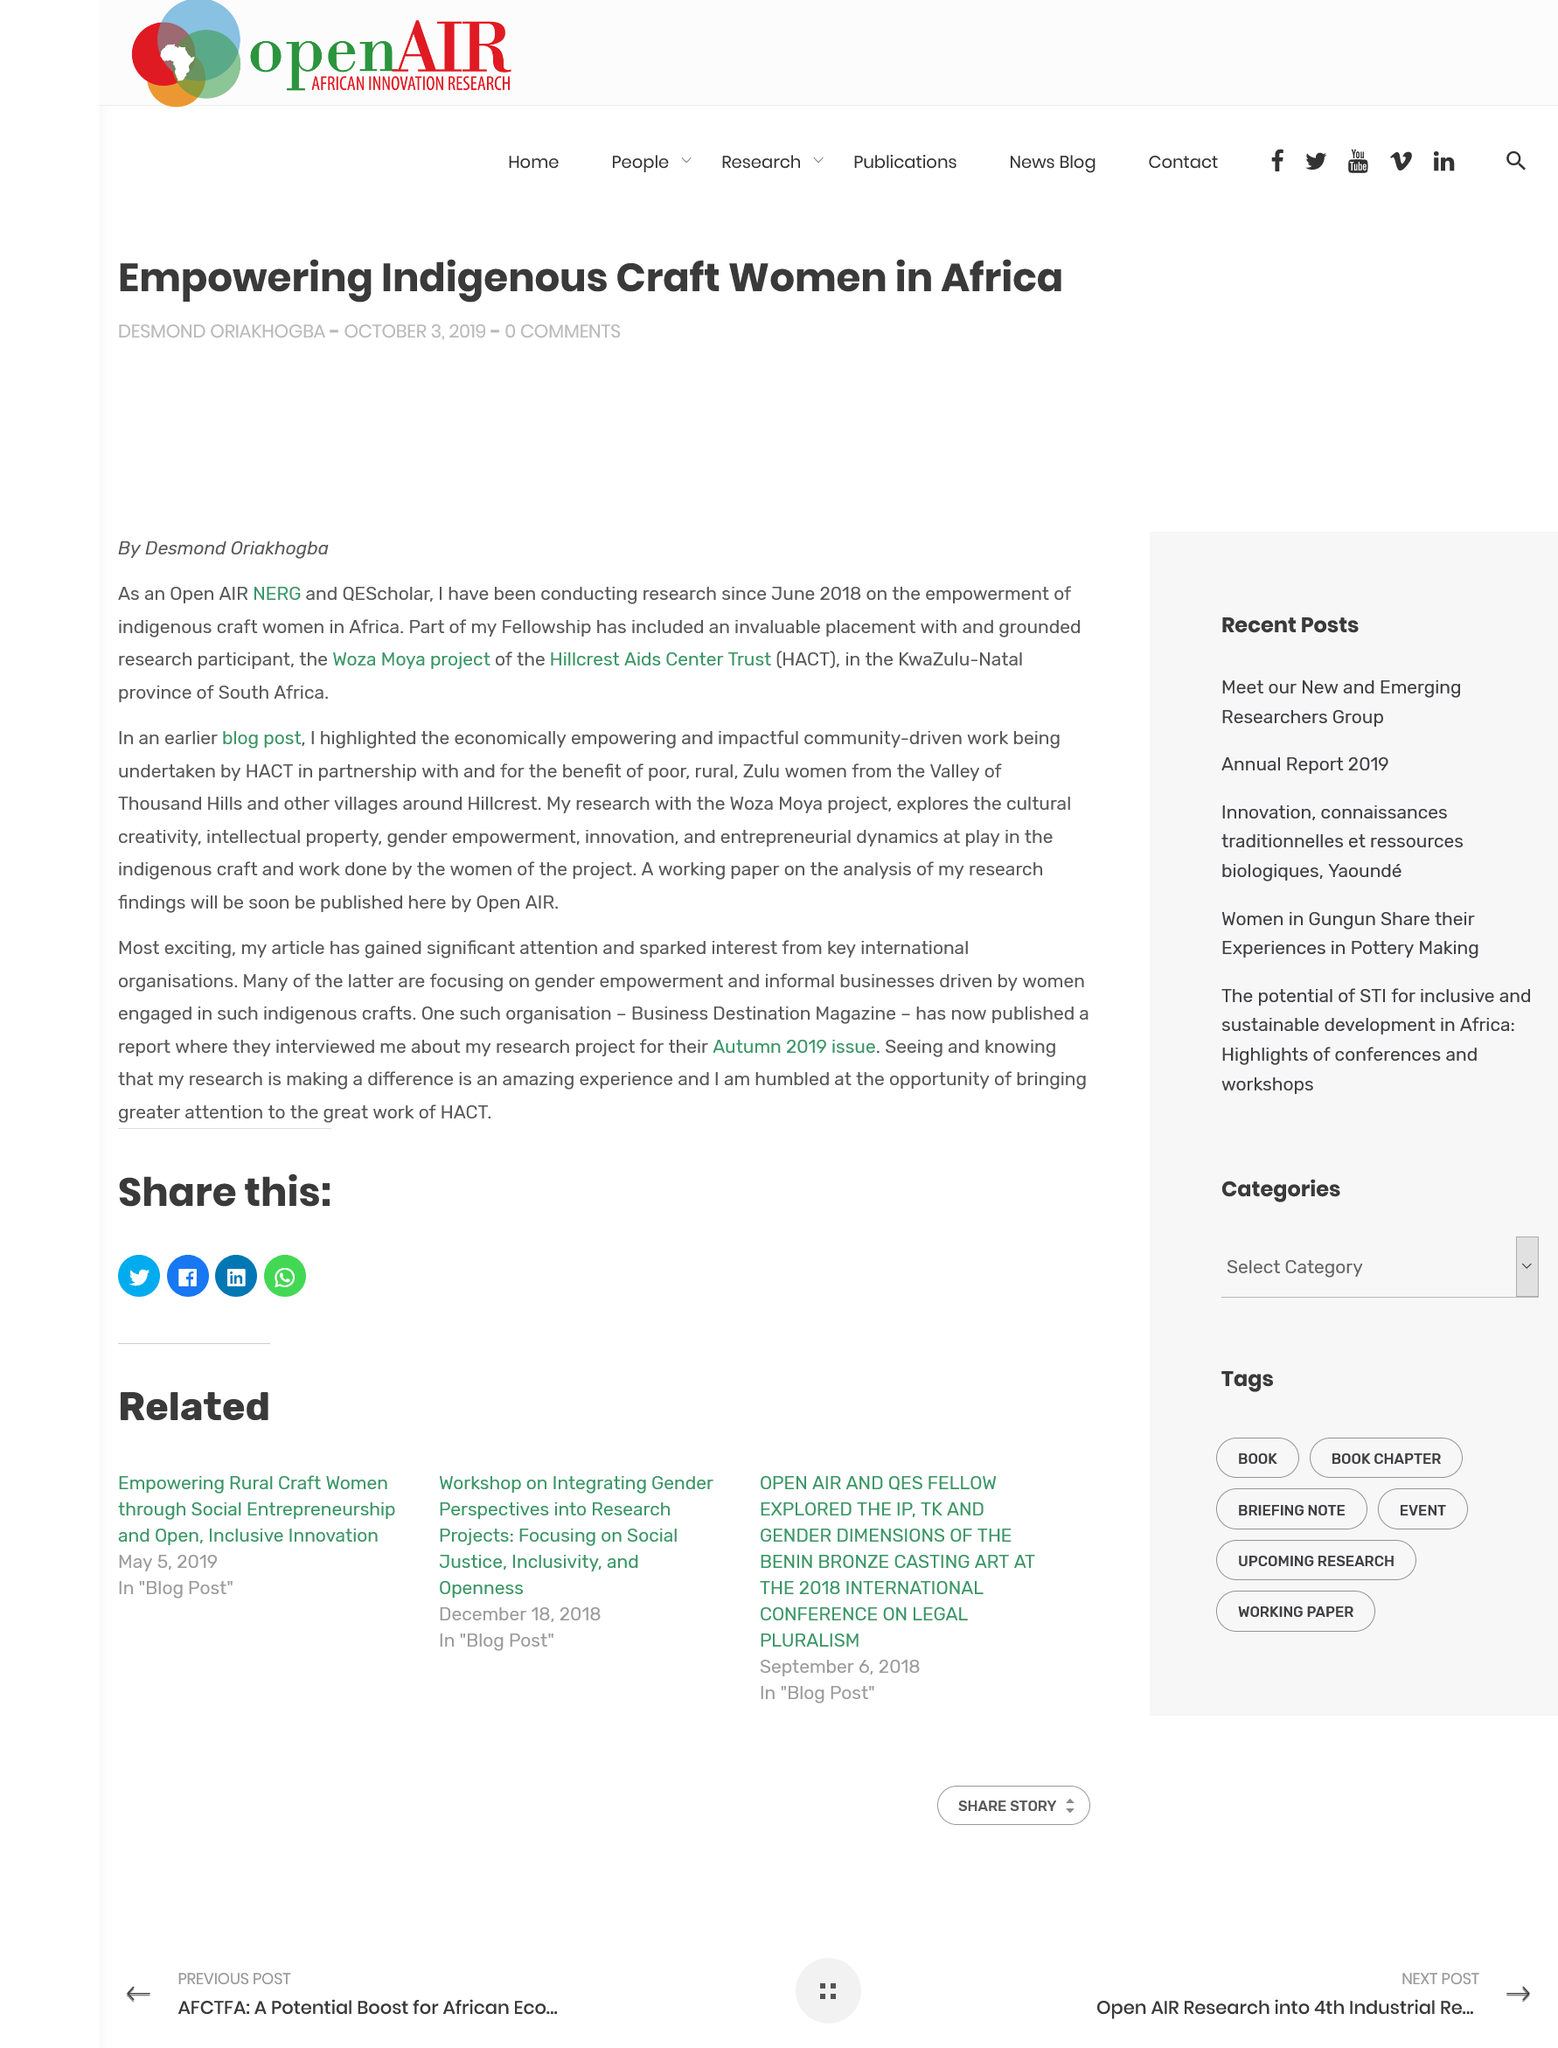Specify some key components in this picture. The author has been conducting research on the empowerment of indigenous craft women in Africa since June 2018. The acronym HACT stands for Hillcrest Aids Center Trust, a non-profit organization dedicated to providing support and services to individuals affected by HIV/AIDS in the Hillcrest neighborhood of San Diego, California. The working paper on the analysis of the author's findings will be published in Open AIR. 